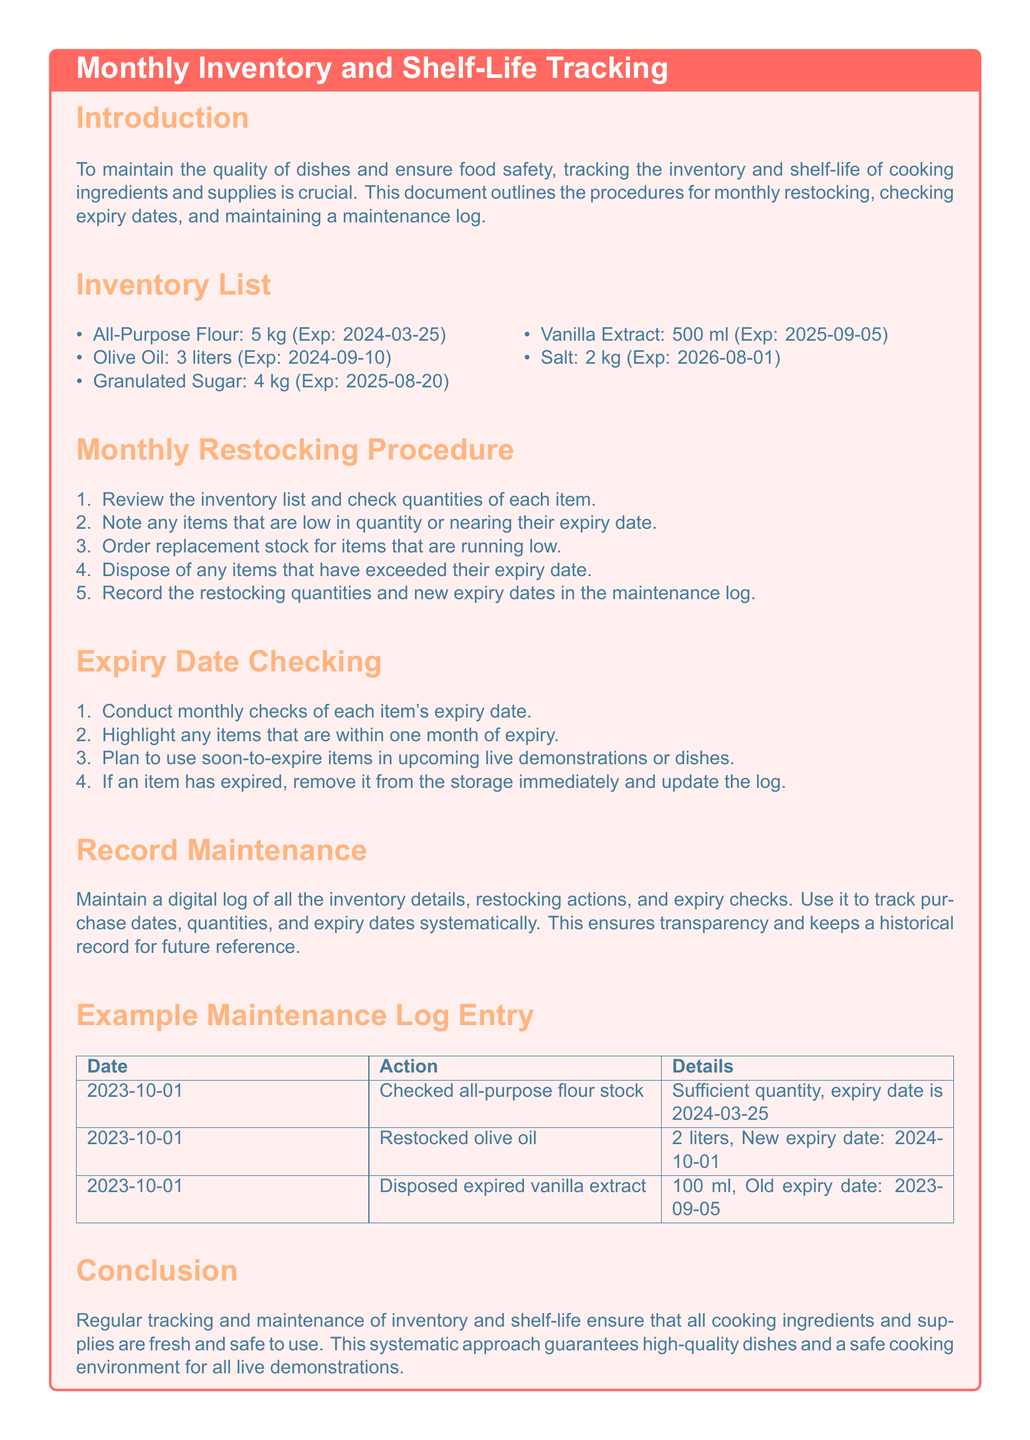what is the expiry date of all-purpose flour? The expiry date for all-purpose flour is explicitly stated in the inventory list as 2024-03-25.
Answer: 2024-03-25 how much olive oil is in stock? The stock level of olive oil is found in the inventory list, which indicates there are 3 liters available.
Answer: 3 liters what action was taken on 2023-10-01 regarding vanilla extract? The maintenance log entry for 2023-10-01 indicates that 100 ml of expired vanilla extract was disposed of.
Answer: Disposed expired vanilla extract which item has the longest shelf life? By comparing the expiry dates of all items, it can be seen that salt has the longest expiry date of 2026-08-01.
Answer: Salt how often should the inventory be checked for expiry dates? The document specifies that expiry dates should be checked monthly as part of the expiry date checking process.
Answer: Monthly what should be done with items nearing their expiry date? The document states that items within one month of expiry should be used in upcoming live demonstrations or dishes.
Answer: Use in upcoming live demonstrations how should restocked items' details be recorded? The procedure indicates that new expiry dates and restocking quantities should be recorded in the maintenance log.
Answer: In the maintenance log what is the total quantity of granulated sugar in stock? The inventory list details that the quantity of granulated sugar is 4 kg.
Answer: 4 kg what is the purpose of maintaining a digital log? The document outlines that the digital log ensures systematic tracking of purchase dates, quantities, and expiry dates.
Answer: Transparency and historical record 